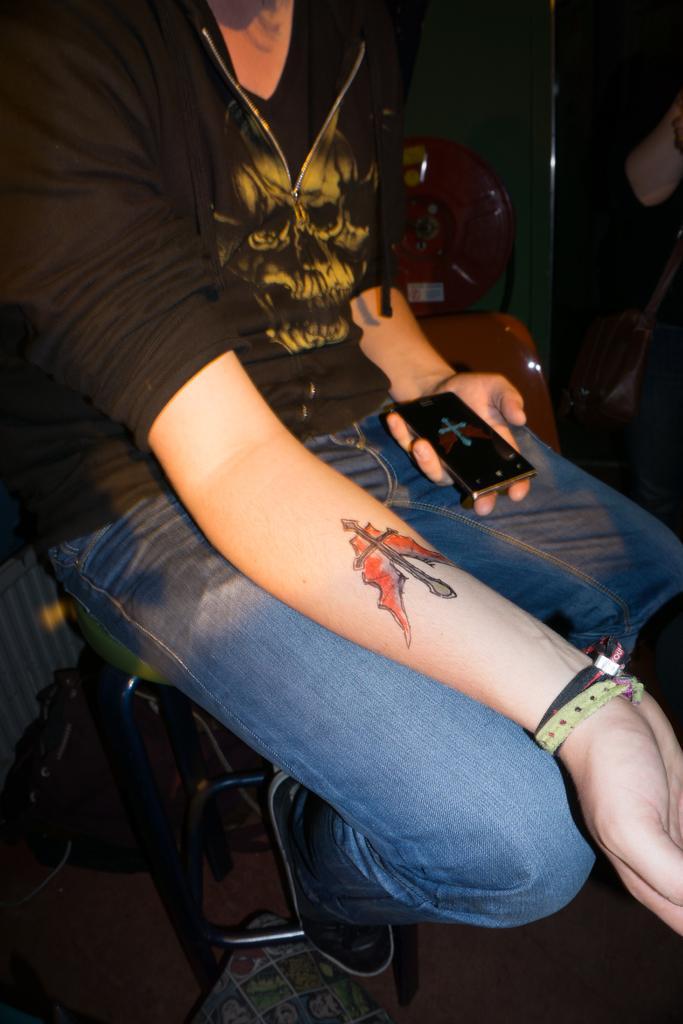Could you give a brief overview of what you see in this image? Here in this picture we can see a woman sitting on a chair over there and we can see tattoo on her arm and she is holding mobile phone in other hand. 